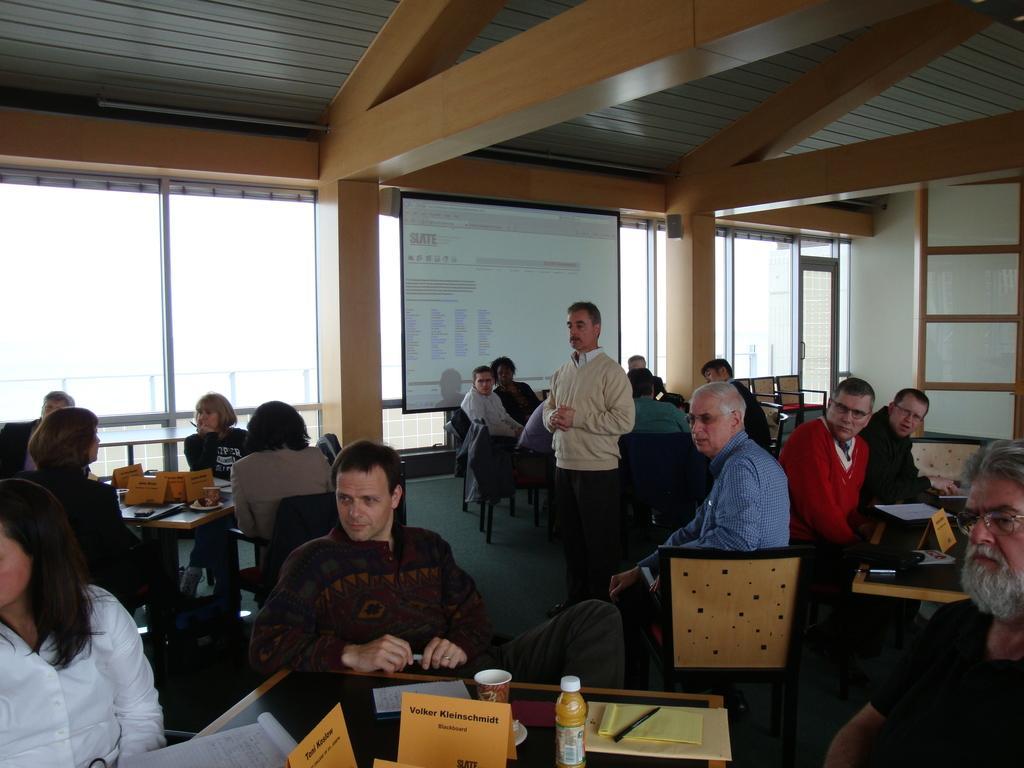In one or two sentences, can you explain what this image depicts? In the image we can see there are people who are sitting on chair and in front of them there is a table and a person is standing in between the people. 